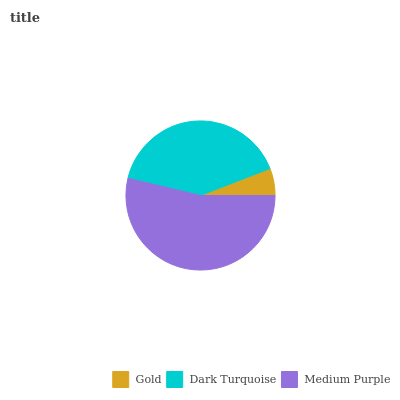Is Gold the minimum?
Answer yes or no. Yes. Is Medium Purple the maximum?
Answer yes or no. Yes. Is Dark Turquoise the minimum?
Answer yes or no. No. Is Dark Turquoise the maximum?
Answer yes or no. No. Is Dark Turquoise greater than Gold?
Answer yes or no. Yes. Is Gold less than Dark Turquoise?
Answer yes or no. Yes. Is Gold greater than Dark Turquoise?
Answer yes or no. No. Is Dark Turquoise less than Gold?
Answer yes or no. No. Is Dark Turquoise the high median?
Answer yes or no. Yes. Is Dark Turquoise the low median?
Answer yes or no. Yes. Is Medium Purple the high median?
Answer yes or no. No. Is Gold the low median?
Answer yes or no. No. 